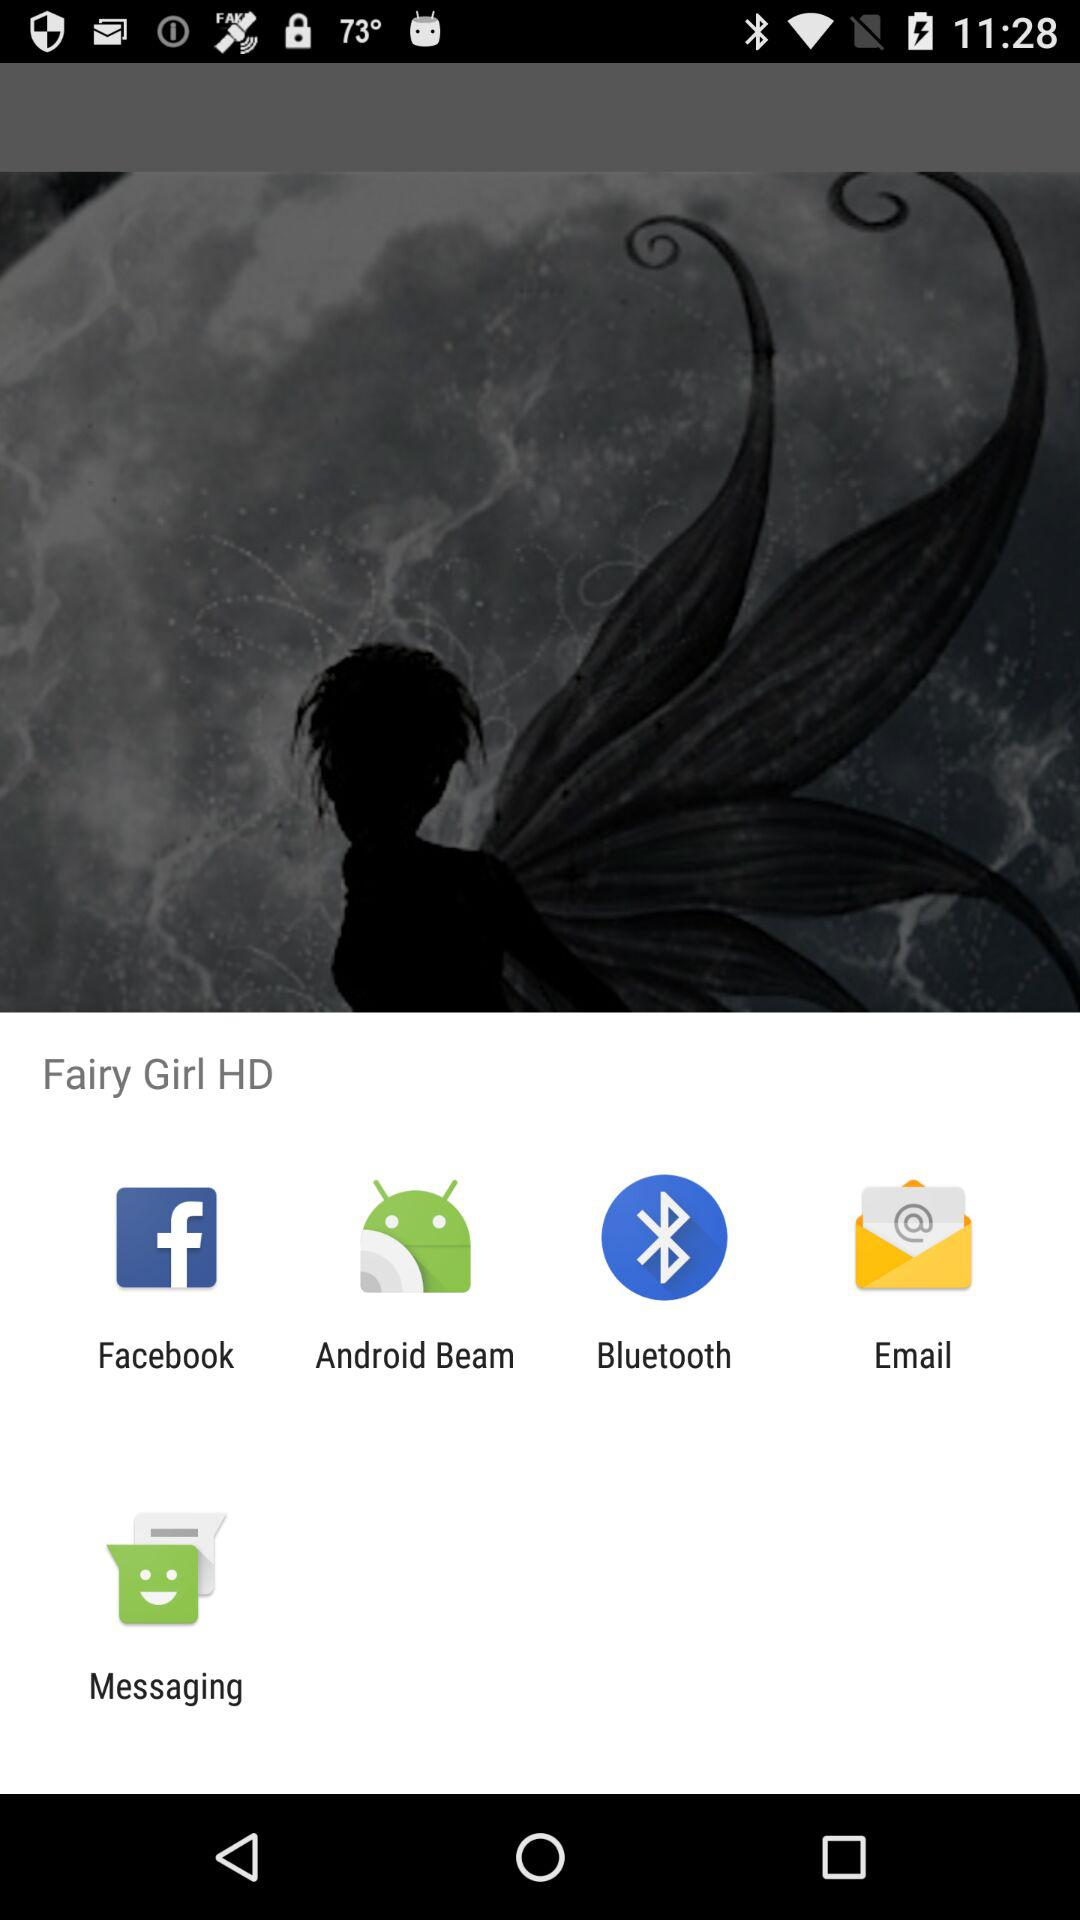What applications can be used to share? The applications "Facebook", "Android Beam", "Bluetooth", "Email" and "Messaging" can be used to share. 